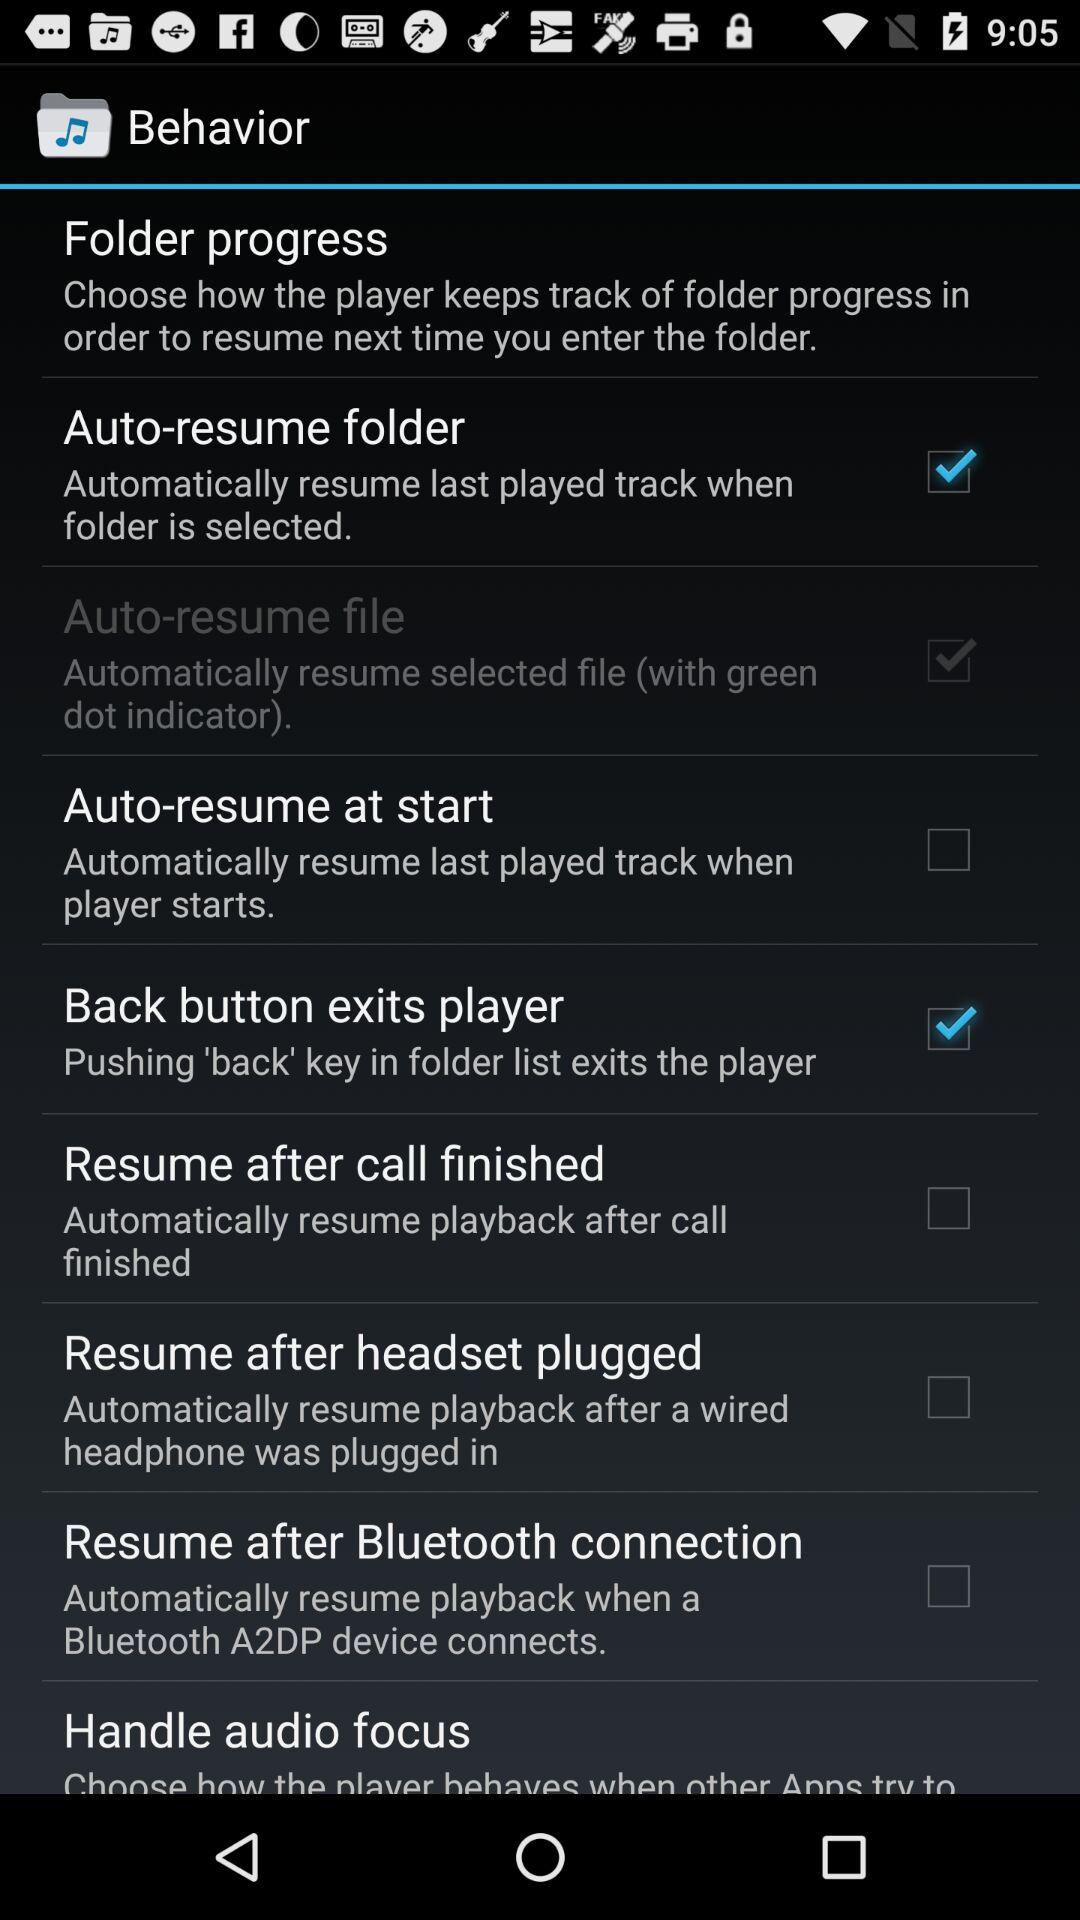How to automatically connect Bluetooth?
When the provided information is insufficient, respond with <no answer>. <no answer> 